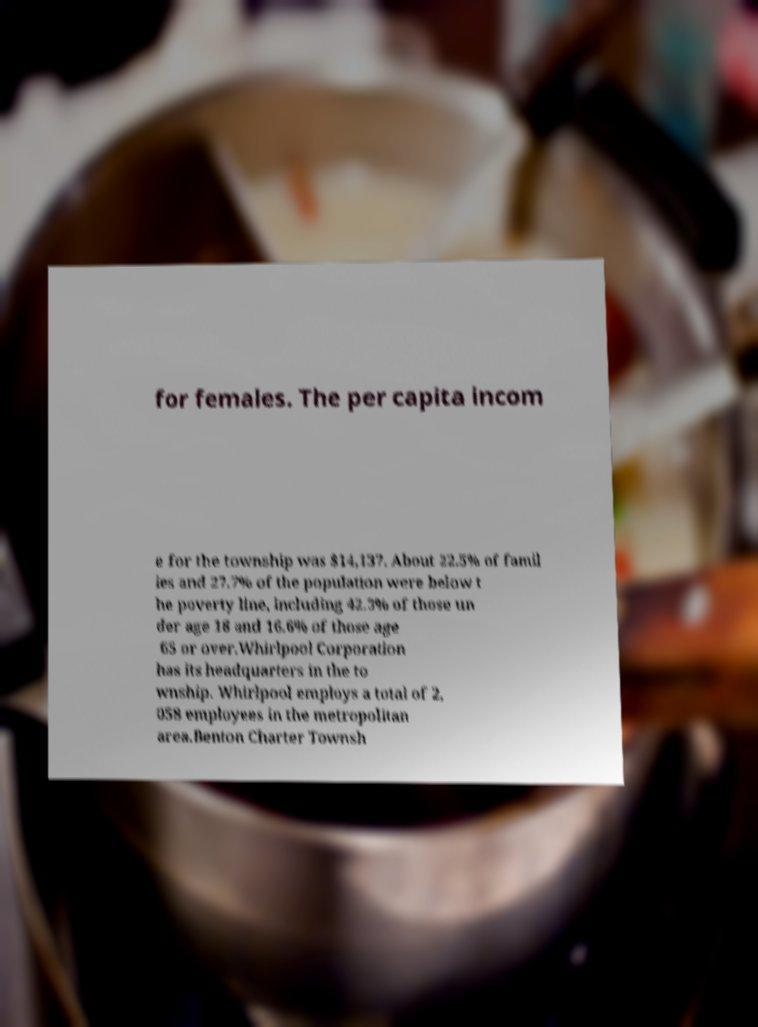Please identify and transcribe the text found in this image. for females. The per capita incom e for the township was $14,137. About 22.5% of famil ies and 27.7% of the population were below t he poverty line, including 42.3% of those un der age 18 and 16.6% of those age 65 or over.Whirlpool Corporation has its headquarters in the to wnship. Whirlpool employs a total of 2, 058 employees in the metropolitan area.Benton Charter Townsh 